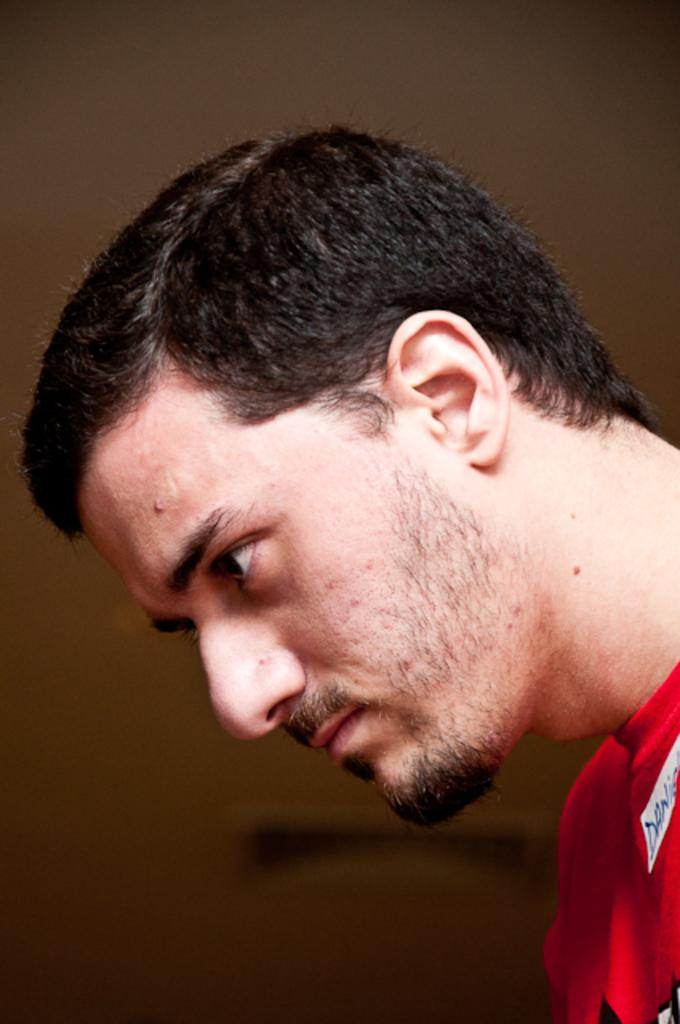Who or what is the main subject of the image? There is a person in the image. What is the person wearing? The person is wearing a red dress. What colors can be seen in the background of the image? The background of the image is in brown and black colors. What type of books can be found in the library depicted in the image? There is no library present in the image; it features a person wearing a red dress against a brown and black background. 